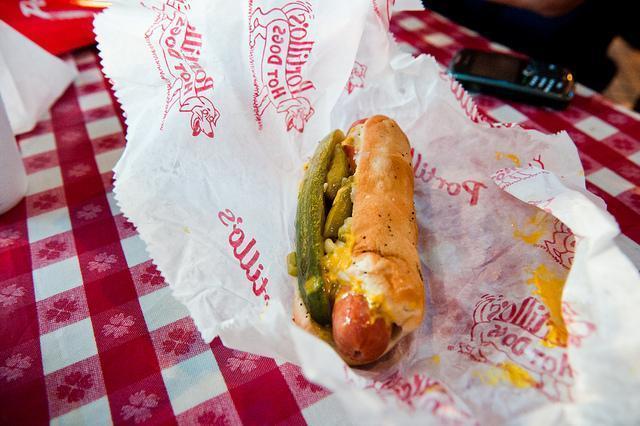How many bottles can be seen?
Give a very brief answer. 1. 